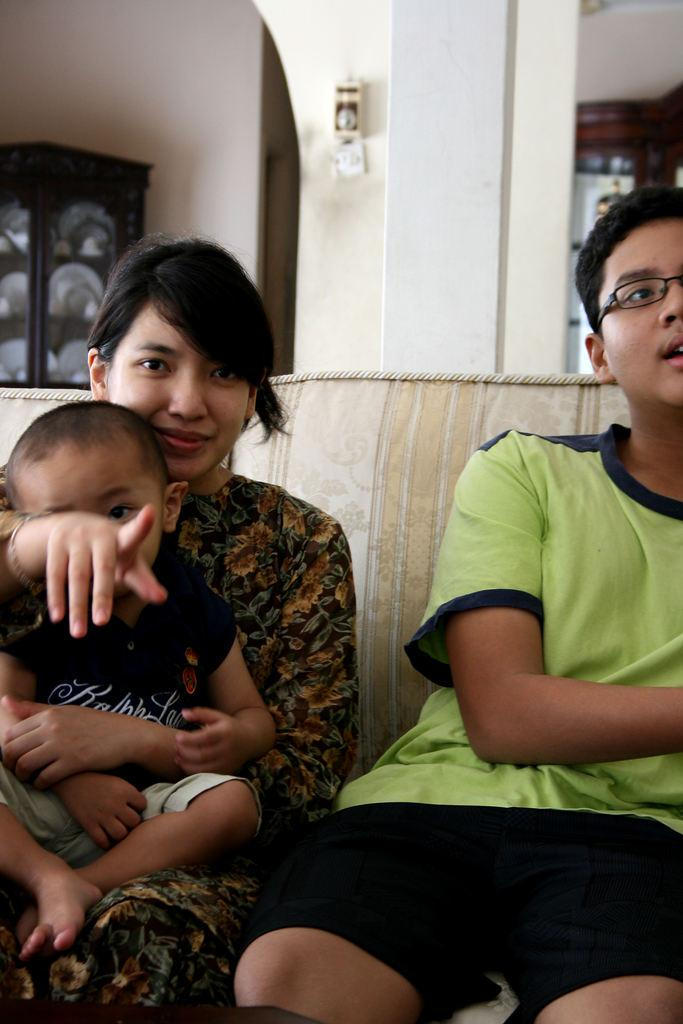What are the people in the image doing? The people in the image are sitting on an object. What can be seen in the background of the image? There is a wall visible in the image. What type of material is used for the objects in the image? There are wooden objects in the image. Can you describe the pillar and the object attached to it? There is a pillar with an object attached to it in the image. What type of kettle is being used to measure the stick's length in the image? There is no kettle or stick present in the image, so it is not possible to answer that question. 